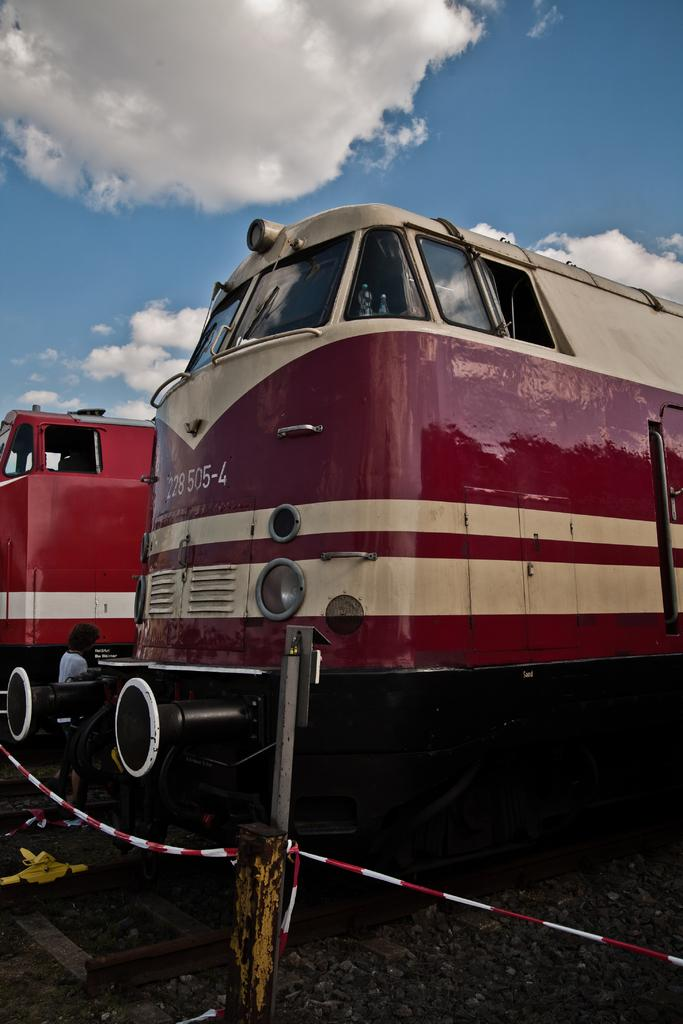What can be seen in the image related to transportation? There are two trains in the image. What else is present in the image besides the trains? There is a barricade in the image. How would you describe the weather based on the image? The sky is cloudy in the image. What type of cup is hanging on the curtain in the image? There is no cup or curtain present in the image. How much debt is visible in the image? There is no mention of debt in the image. 